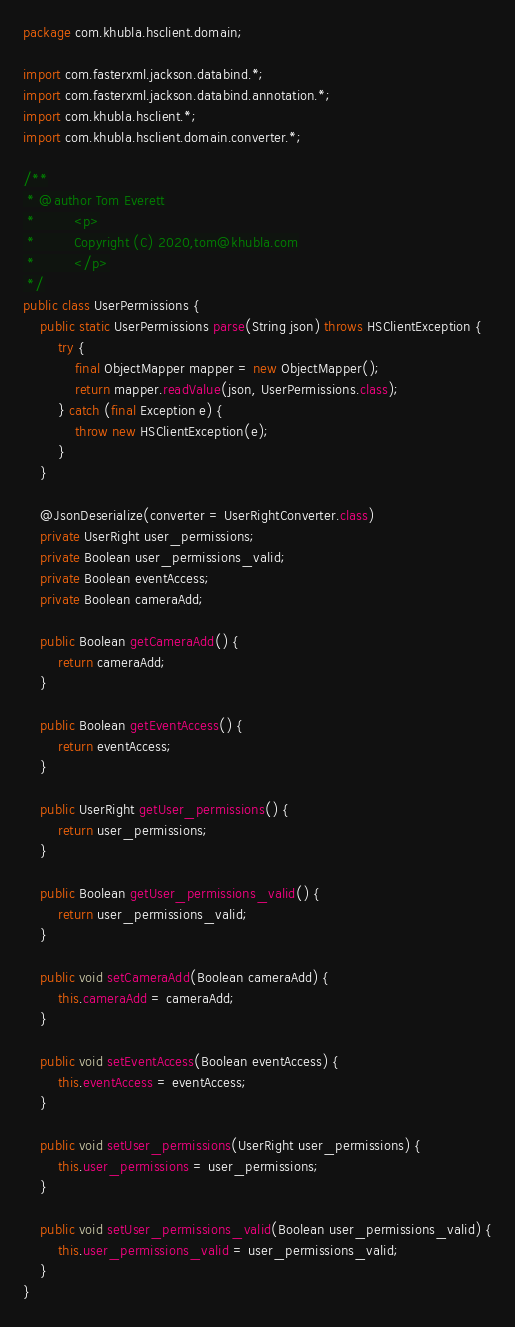<code> <loc_0><loc_0><loc_500><loc_500><_Java_>package com.khubla.hsclient.domain;

import com.fasterxml.jackson.databind.*;
import com.fasterxml.jackson.databind.annotation.*;
import com.khubla.hsclient.*;
import com.khubla.hsclient.domain.converter.*;

/**
 * @author Tom Everett
 *         <p>
 *         Copyright (C) 2020,tom@khubla.com
 *         </p>
 */
public class UserPermissions {
	public static UserPermissions parse(String json) throws HSClientException {
		try {
			final ObjectMapper mapper = new ObjectMapper();
			return mapper.readValue(json, UserPermissions.class);
		} catch (final Exception e) {
			throw new HSClientException(e);
		}
	}

	@JsonDeserialize(converter = UserRightConverter.class)
	private UserRight user_permissions;
	private Boolean user_permissions_valid;
	private Boolean eventAccess;
	private Boolean cameraAdd;

	public Boolean getCameraAdd() {
		return cameraAdd;
	}

	public Boolean getEventAccess() {
		return eventAccess;
	}

	public UserRight getUser_permissions() {
		return user_permissions;
	}

	public Boolean getUser_permissions_valid() {
		return user_permissions_valid;
	}

	public void setCameraAdd(Boolean cameraAdd) {
		this.cameraAdd = cameraAdd;
	}

	public void setEventAccess(Boolean eventAccess) {
		this.eventAccess = eventAccess;
	}

	public void setUser_permissions(UserRight user_permissions) {
		this.user_permissions = user_permissions;
	}

	public void setUser_permissions_valid(Boolean user_permissions_valid) {
		this.user_permissions_valid = user_permissions_valid;
	}
}
</code> 